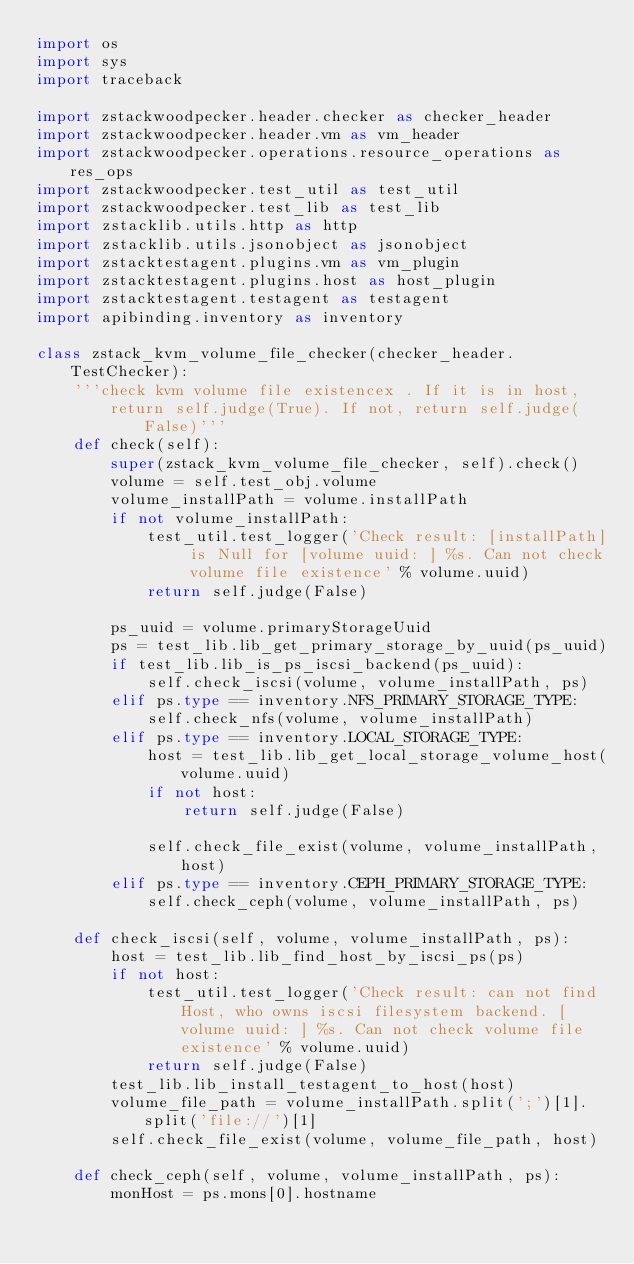Convert code to text. <code><loc_0><loc_0><loc_500><loc_500><_Python_>import os
import sys
import traceback

import zstackwoodpecker.header.checker as checker_header
import zstackwoodpecker.header.vm as vm_header
import zstackwoodpecker.operations.resource_operations as res_ops
import zstackwoodpecker.test_util as test_util
import zstackwoodpecker.test_lib as test_lib
import zstacklib.utils.http as http
import zstacklib.utils.jsonobject as jsonobject
import zstacktestagent.plugins.vm as vm_plugin
import zstacktestagent.plugins.host as host_plugin
import zstacktestagent.testagent as testagent
import apibinding.inventory as inventory

class zstack_kvm_volume_file_checker(checker_header.TestChecker):
    '''check kvm volume file existencex . If it is in host, 
        return self.judge(True). If not, return self.judge(False)'''
    def check(self):
        super(zstack_kvm_volume_file_checker, self).check()
        volume = self.test_obj.volume
        volume_installPath = volume.installPath
        if not volume_installPath:
            test_util.test_logger('Check result: [installPath] is Null for [volume uuid: ] %s. Can not check volume file existence' % volume.uuid)
            return self.judge(False)

        ps_uuid = volume.primaryStorageUuid
        ps = test_lib.lib_get_primary_storage_by_uuid(ps_uuid)
        if test_lib.lib_is_ps_iscsi_backend(ps_uuid):
            self.check_iscsi(volume, volume_installPath, ps)
        elif ps.type == inventory.NFS_PRIMARY_STORAGE_TYPE:
            self.check_nfs(volume, volume_installPath)
        elif ps.type == inventory.LOCAL_STORAGE_TYPE:
            host = test_lib.lib_get_local_storage_volume_host(volume.uuid)
            if not host:
                return self.judge(False)

            self.check_file_exist(volume, volume_installPath, host)
        elif ps.type == inventory.CEPH_PRIMARY_STORAGE_TYPE:
            self.check_ceph(volume, volume_installPath, ps)

    def check_iscsi(self, volume, volume_installPath, ps):
        host = test_lib.lib_find_host_by_iscsi_ps(ps)
        if not host:
            test_util.test_logger('Check result: can not find Host, who owns iscsi filesystem backend. [volume uuid: ] %s. Can not check volume file existence' % volume.uuid)
            return self.judge(False)
        test_lib.lib_install_testagent_to_host(host)
        volume_file_path = volume_installPath.split(';')[1].split('file://')[1]
        self.check_file_exist(volume, volume_file_path, host)

    def check_ceph(self, volume, volume_installPath, ps):
        monHost = ps.mons[0].hostname</code> 